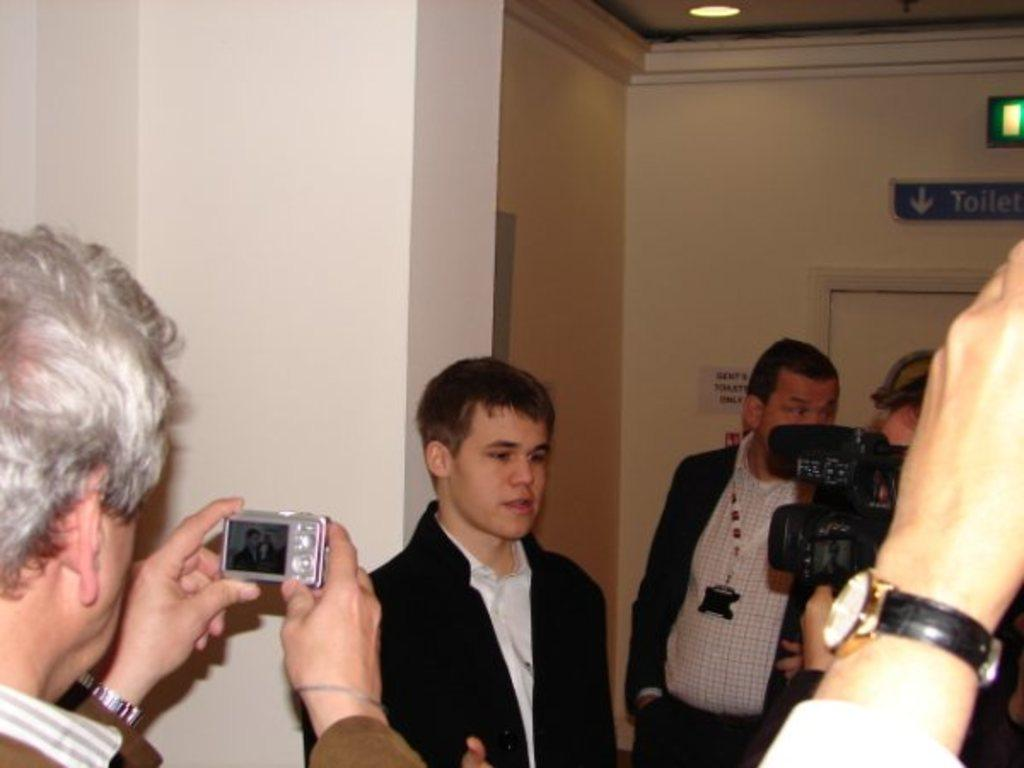What is the color of the wall in the image? The wall in the image is white. What can be seen in front of the wall? There are people standing in the image. What is the man holding in the image? The man is holding a camera in the image. How many people are exchanging bites of food in the image? There is no exchange of food or bites in the image; the focus is on the wall, people, and the man holding a camera. 